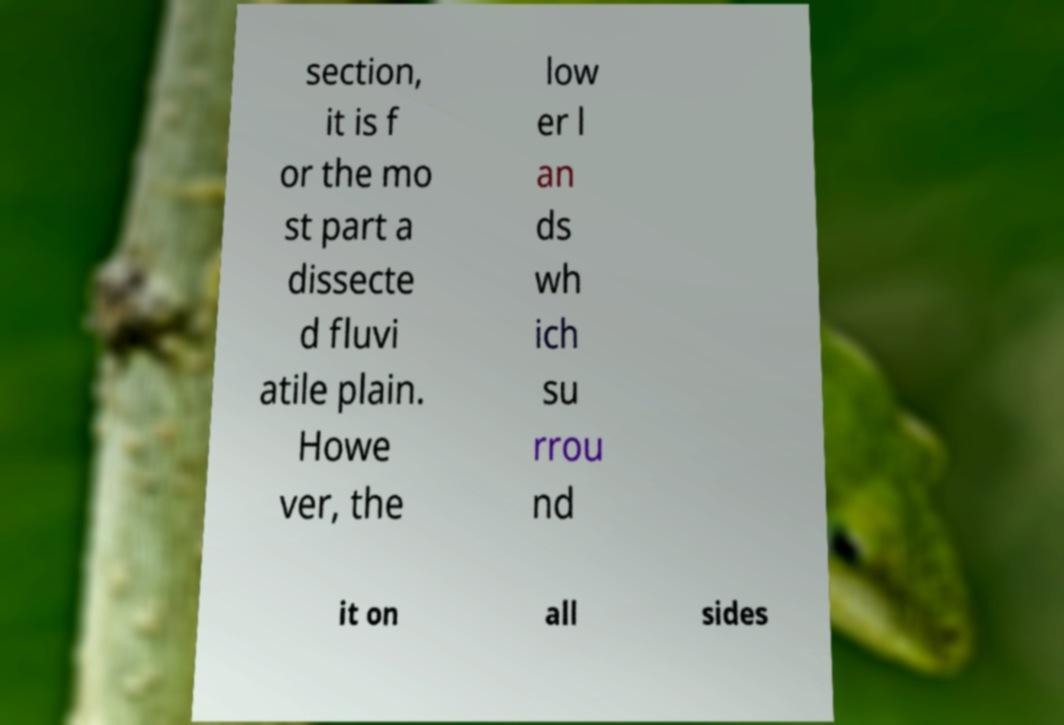What messages or text are displayed in this image? I need them in a readable, typed format. section, it is f or the mo st part a dissecte d fluvi atile plain. Howe ver, the low er l an ds wh ich su rrou nd it on all sides 